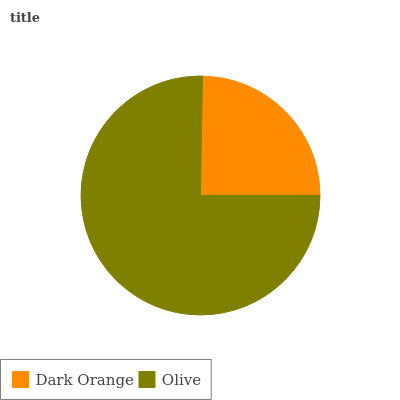Is Dark Orange the minimum?
Answer yes or no. Yes. Is Olive the maximum?
Answer yes or no. Yes. Is Olive the minimum?
Answer yes or no. No. Is Olive greater than Dark Orange?
Answer yes or no. Yes. Is Dark Orange less than Olive?
Answer yes or no. Yes. Is Dark Orange greater than Olive?
Answer yes or no. No. Is Olive less than Dark Orange?
Answer yes or no. No. Is Olive the high median?
Answer yes or no. Yes. Is Dark Orange the low median?
Answer yes or no. Yes. Is Dark Orange the high median?
Answer yes or no. No. Is Olive the low median?
Answer yes or no. No. 